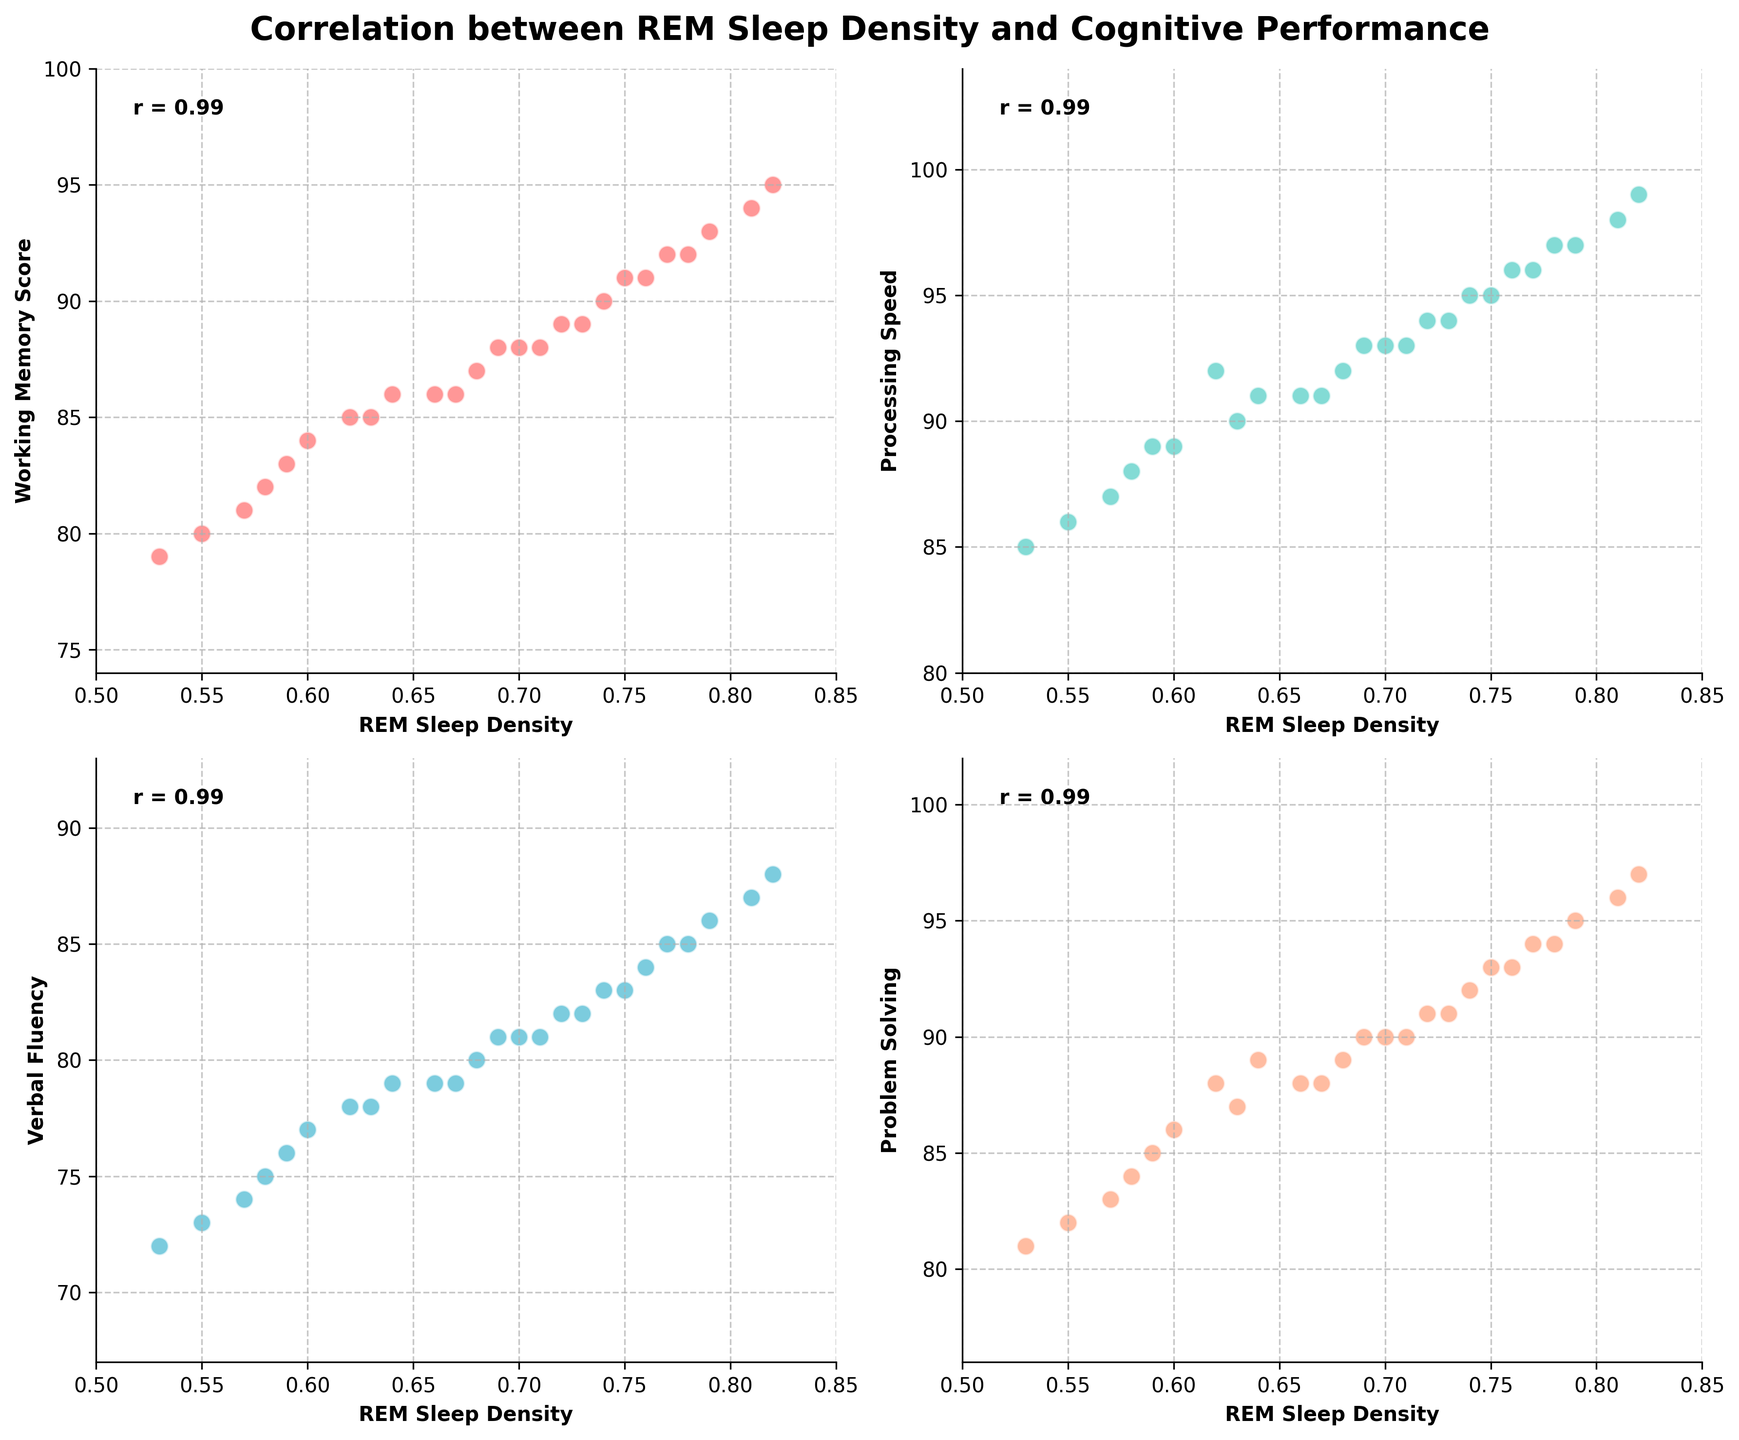How many cognitive performance measures show a positive correlation with REM sleep density? To determine the number of cognitive performance measures with a positive correlation, look for the correlation coefficient (r) value annotated on each subplot. A positive correlation is indicated by r > 0. All four subplots show positive r values.
Answer: 4 Which cognitive measure has the highest correlation with REM sleep density? Examine the correlation coefficients (r values) annotated on the subplots. The measure with the highest r value has the strongest correlation. "Processing Speed" has the highest correlation coefficient.
Answer: Processing Speed Compare the correlations of 'verbal fluency' and 'working memory score' with REM sleep density. Which one is higher and by how much? Identify the r values for both 'verbal fluency' and 'working_memory_score' from their respective subplots. Subtract the smaller r value from the larger one. "Verbal Fluency" has r ≈ 0.92 and "Working Memory Score" has r ≈ 0.88. The difference is 0.04.
Answer: Verbal Fluency by 0.04 What are the colors representing the scatter plots for 'problem solving' and 'working memory score'? Identify the colors of the points plotted in the respective subplots for each measure. "Problem Solving" uses an orange-like color, and "Working Memory Score" uses a red-like color.
Answer: Orange, Red Which subplot has data points that visually appear densest, and what might that indicate? Examine each subplot to see which has the tightest cluster of data points. The subplot for 'processing speed' appears densest, indicating less variance among data points and potentially a stronger relationship with REM sleep density.
Answer: Processing Speed Which cognitive measure has the lowest correlation with REM sleep density, and what is its r value? Identify the measure with the lowest r value annotated on the subplots. "Working Memory Score" has the lowest correlation coefficient, r ≈ 0.88.
Answer: Working Memory Score, r ≈ 0.88 Is there a cognitive performance measure where the majority of data points fall above a score of 90? Observe each subplot to see the distribution of data points relative to the score of 90. The 'Processing Speed' plot shows most points above 90.
Answer: Processing Speed How do the scores for 'problem solving' compare to the scores for 'verbal fluency'? Compare the data points in the 'Problem Solving' and 'Verbal Fluency' subplots by looking at their ranges. Both sets of scores mostly fall within the 72-97 range, but 'Problem Solving' tends to have slightly higher scores.
Answer: Problem Solving has slightly higher scores What is the general trend indicated by each scatter plot in terms of REM sleep density and cognitive performance? Analyze each subplot to see the direction of the trend of data points. Each plot shows an upward trend, indicating that higher REM sleep density generally correlates with higher cognitive performance measures.
Answer: Upward Trend For the 'processing speed' plot, within what range do the scores predominantly lie? By looking at the x and y-axis limits and the distribution of data points, it is evident that most scores lie between 85 and 99 for 'Processing Speed'.
Answer: 85-99 